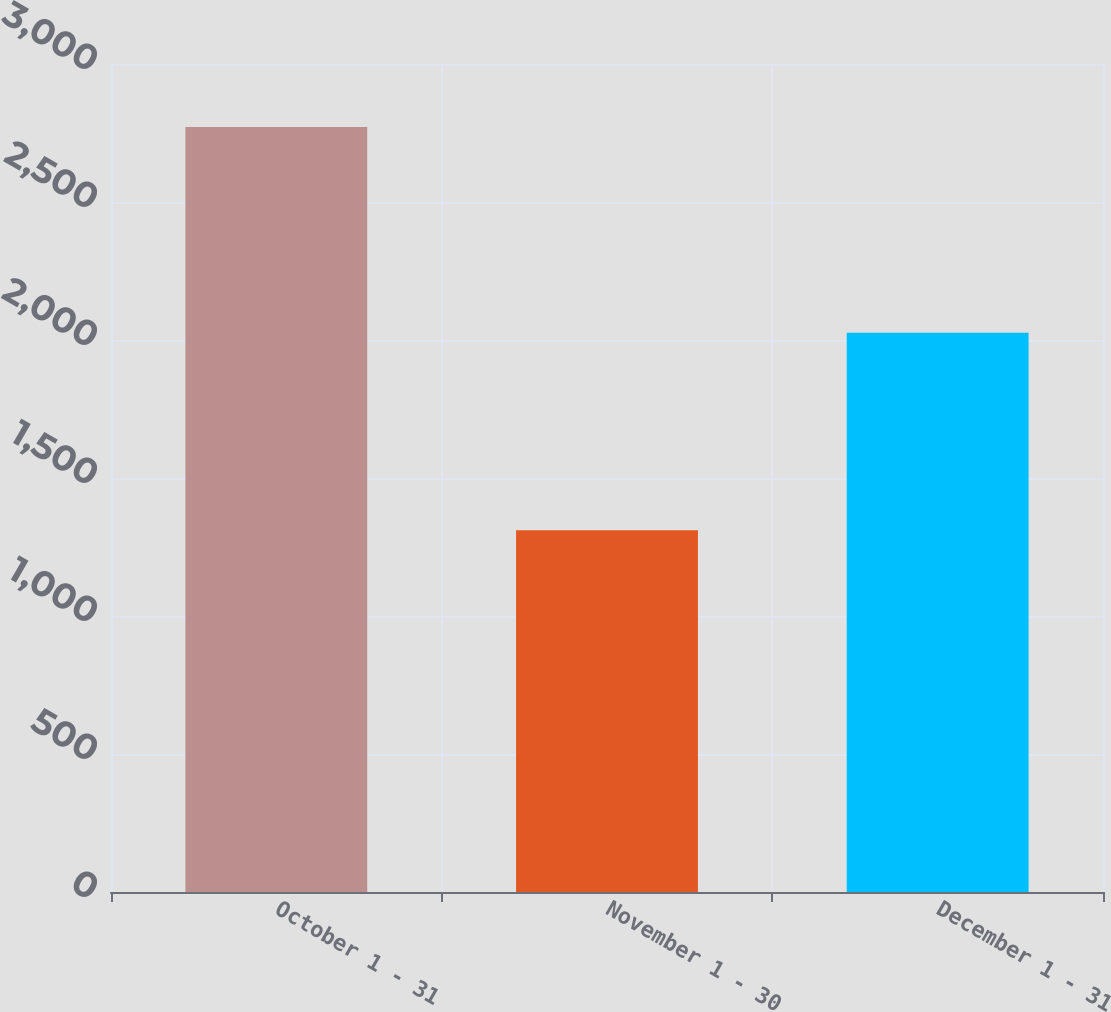Convert chart. <chart><loc_0><loc_0><loc_500><loc_500><bar_chart><fcel>October 1 - 31<fcel>November 1 - 30<fcel>December 1 - 31<nl><fcel>2772<fcel>1311<fcel>2026<nl></chart> 